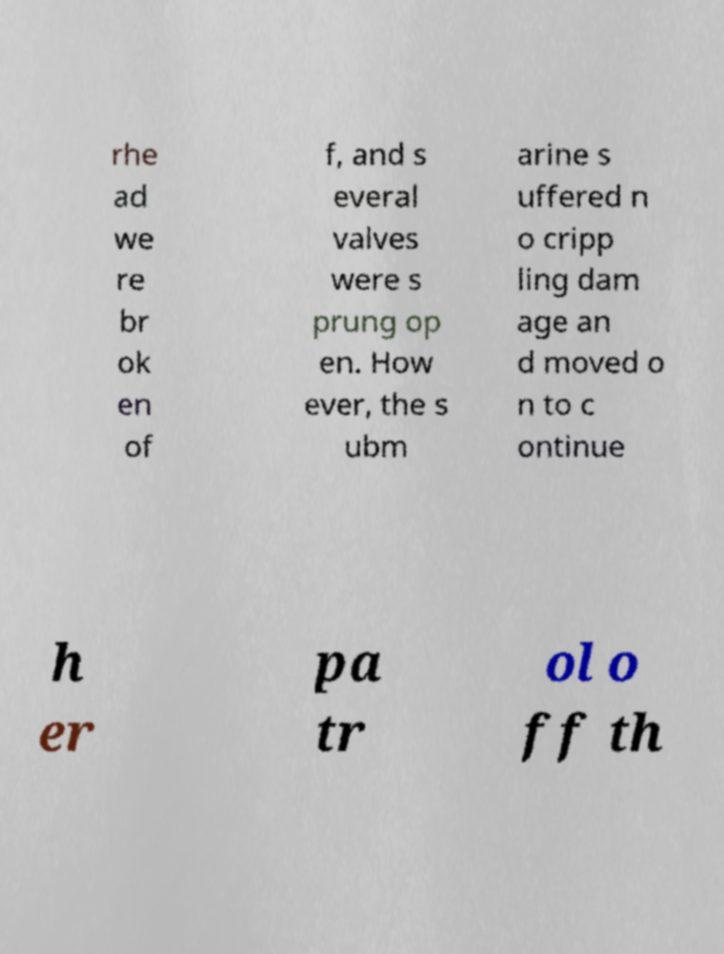Can you accurately transcribe the text from the provided image for me? rhe ad we re br ok en of f, and s everal valves were s prung op en. How ever, the s ubm arine s uffered n o cripp ling dam age an d moved o n to c ontinue h er pa tr ol o ff th 